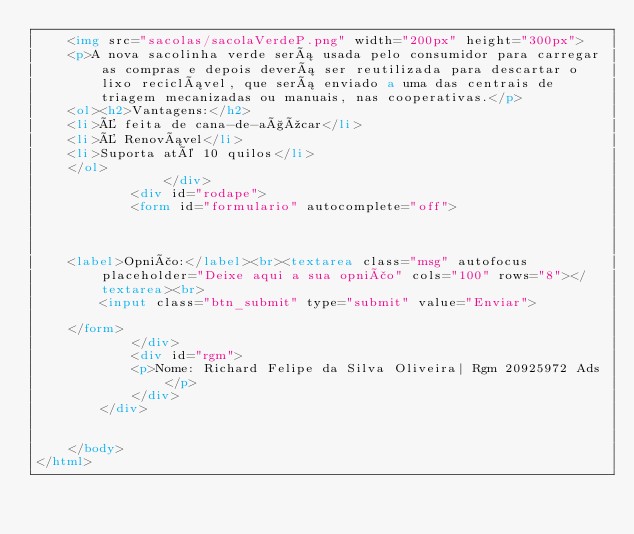Convert code to text. <code><loc_0><loc_0><loc_500><loc_500><_HTML_>    <img src="sacolas/sacolaVerdeP.png" width="200px" height="300px">
    <p>A nova sacolinha verde será usada pelo consumidor para carregar as compras e depois deverá ser reutilizada para descartar o lixo reciclável, que será enviado a uma das centrais de triagem mecanizadas ou manuais, nas cooperativas.</p>
    <ol><h2>Vantagens:</h2>
    <li>É feita de cana-de-açúcar</li>
    <li>É Renovável</li>
    <li>Suporta até 10 quilos</li>
    </ol>
                </div>
            <div id="rodape">
            <form id="formulario" autocomplete="off">
      
        
       
    <label>Opnião:</label><br><textarea class="msg" autofocus placeholder="Deixe aqui a sua opnião" cols="100" rows="8"></textarea><br>
        <input class="btn_submit" type="submit" value="Enviar">
      
    </form>
            </div>
            <div id="rgm">
            <p>Nome: Richard Felipe da Silva Oliveira| Rgm 20925972 Ads </p>
            </div>
        </div>
    
    
    </body>
</html></code> 